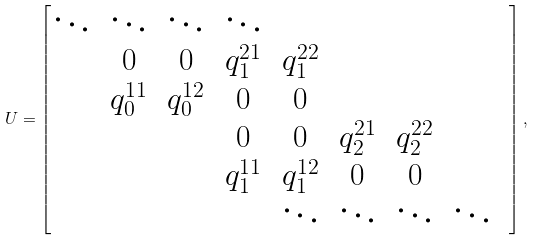<formula> <loc_0><loc_0><loc_500><loc_500>U = \begin{bmatrix} \ddots & \ddots & \ddots & \ddots & & & & & \\ & 0 & 0 & q _ { 1 } ^ { 2 1 } & q _ { 1 } ^ { 2 2 } & & & \\ & q _ { 0 } ^ { 1 1 } & q _ { 0 } ^ { 1 2 } & 0 & 0 & & & \\ & & & 0 & 0 & q _ { 2 } ^ { 2 1 } & q _ { 2 } ^ { 2 2 } & \\ & & & q _ { 1 } ^ { 1 1 } & q _ { 1 } ^ { 1 2 } & 0 & 0 & \\ & & & & \ddots & \ddots & \ddots & \ddots \end{bmatrix} ,</formula> 